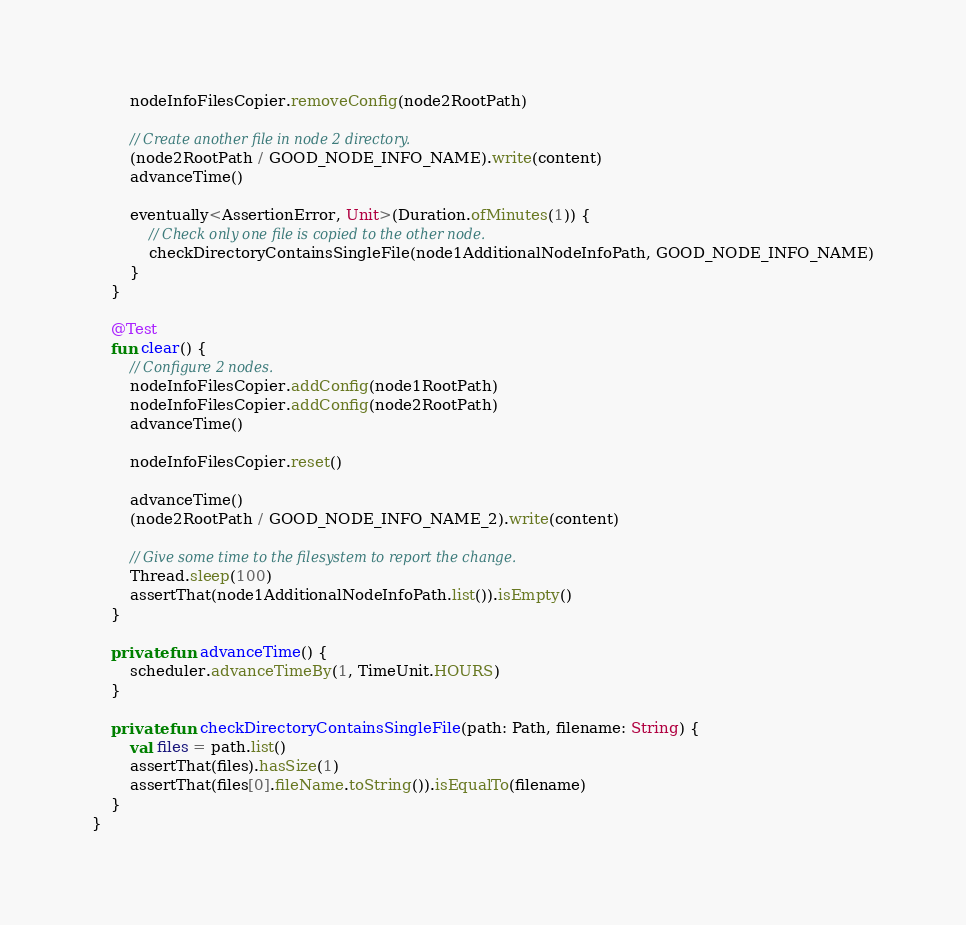Convert code to text. <code><loc_0><loc_0><loc_500><loc_500><_Kotlin_>        nodeInfoFilesCopier.removeConfig(node2RootPath)

        // Create another file in node 2 directory.
        (node2RootPath / GOOD_NODE_INFO_NAME).write(content)
        advanceTime()

        eventually<AssertionError, Unit>(Duration.ofMinutes(1)) {
            // Check only one file is copied to the other node.
            checkDirectoryContainsSingleFile(node1AdditionalNodeInfoPath, GOOD_NODE_INFO_NAME)
        }
    }

    @Test
    fun clear() {
        // Configure 2 nodes.
        nodeInfoFilesCopier.addConfig(node1RootPath)
        nodeInfoFilesCopier.addConfig(node2RootPath)
        advanceTime()

        nodeInfoFilesCopier.reset()

        advanceTime()
        (node2RootPath / GOOD_NODE_INFO_NAME_2).write(content)

        // Give some time to the filesystem to report the change.
        Thread.sleep(100)
        assertThat(node1AdditionalNodeInfoPath.list()).isEmpty()
    }

    private fun advanceTime() {
        scheduler.advanceTimeBy(1, TimeUnit.HOURS)
    }

    private fun checkDirectoryContainsSingleFile(path: Path, filename: String) {
        val files = path.list()
        assertThat(files).hasSize(1)
        assertThat(files[0].fileName.toString()).isEqualTo(filename)
    }
}</code> 